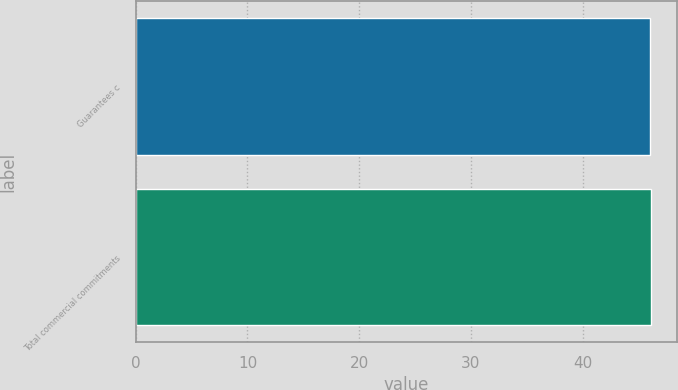Convert chart to OTSL. <chart><loc_0><loc_0><loc_500><loc_500><bar_chart><fcel>Guarantees c<fcel>Total commercial commitments<nl><fcel>46<fcel>46.1<nl></chart> 